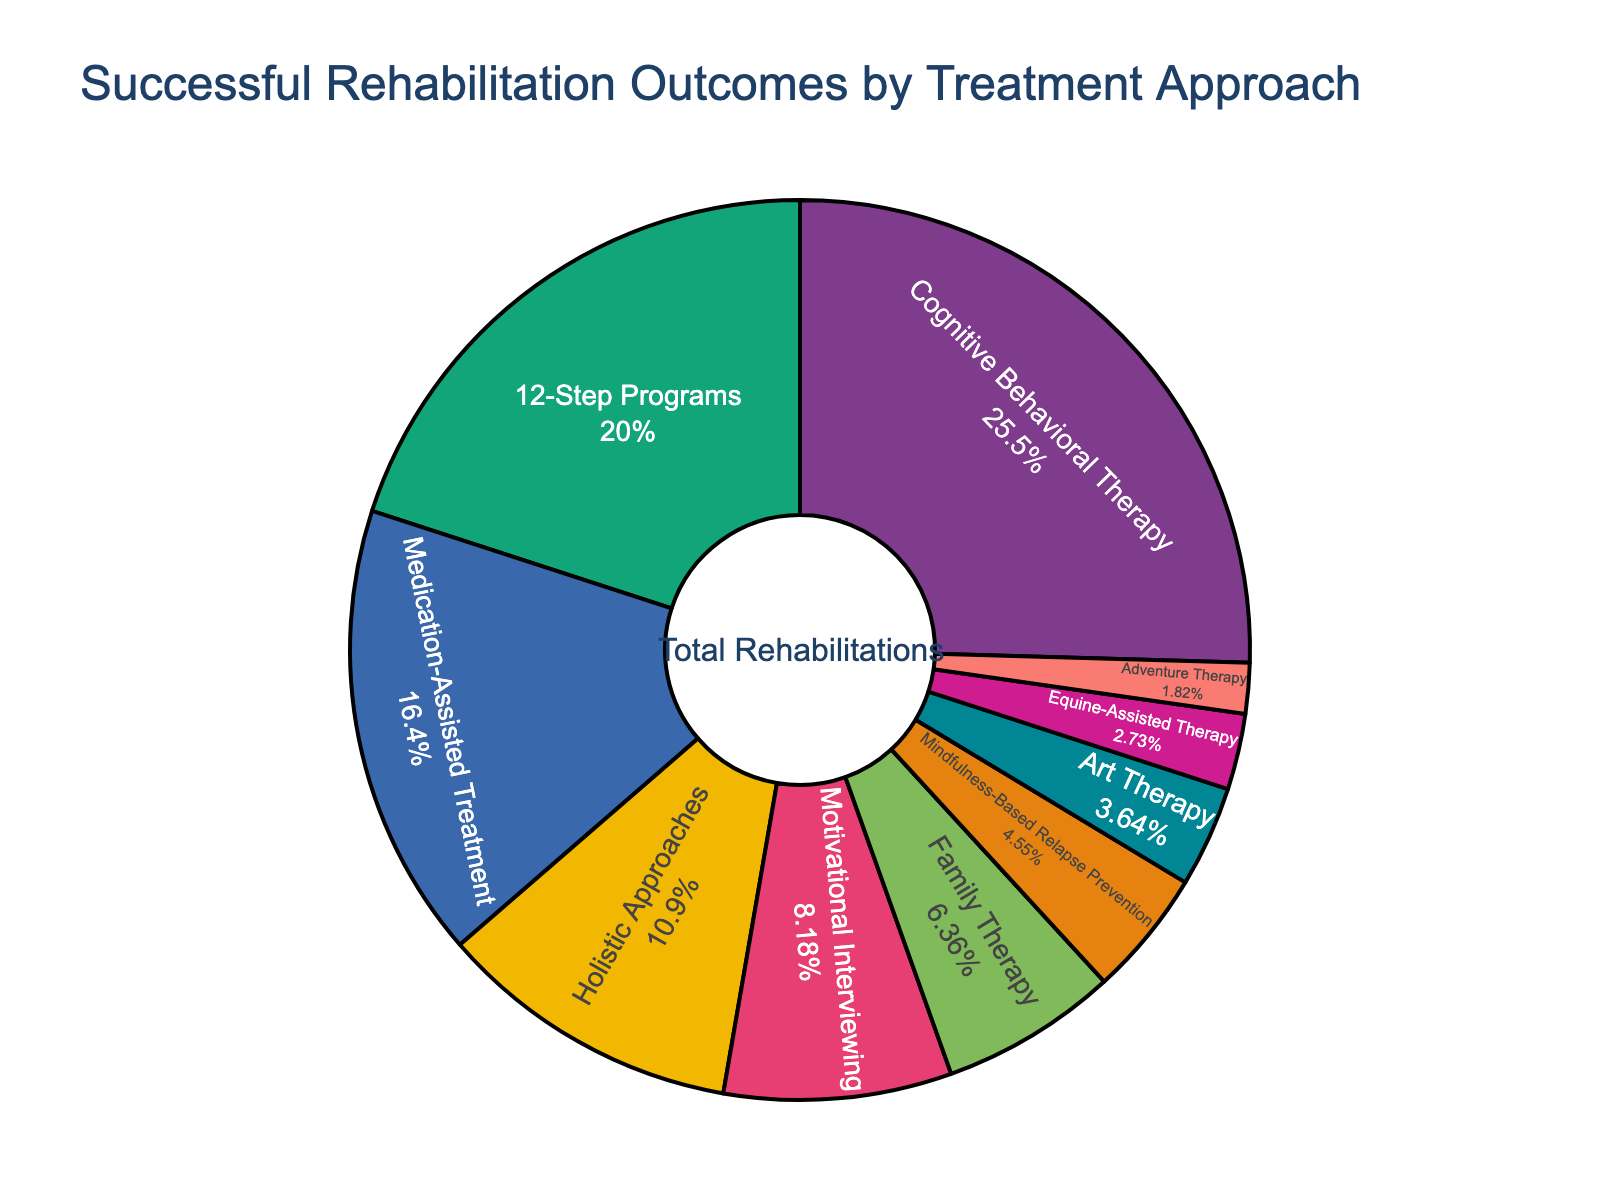What's the dominant treatment approach in terms of successful rehabilitation outcomes? To find the dominant treatment approach, look for the segment with the highest percentage on the pie chart. The "Cognitive Behavioral Therapy" segment is the largest, accounting for 28%.
Answer: Cognitive Behavioral Therapy Which treatment approach is the least effective based on the percentage of successful rehabilitation outcomes? To determine the least effective approach, identify the segment with the smallest percentage in the pie chart. "Adventure Therapy" has the smallest segment at 2%.
Answer: Adventure Therapy What is the combined percentage of successful outcomes for "12-Step Programs" and "Medication-Assisted Treatment"? Sum the percentages for "12-Step Programs" (22%) and "Medication-Assisted Treatment" (18%). The total is 22% + 18% = 40%.
Answer: 40% How does "Family Therapy" compare to "Holistic Approaches" in terms of successful rehabilitation outcomes? Compare the percentages of "Family Therapy" (7%) and "Holistic Approaches" (12%). "Holistic Approaches" has a higher percentage than "Family Therapy".
Answer: Holistic Approaches has a higher percentage Which treatment approaches together make up more than 50% of the successful outcomes? Calculate the cumulative percentages in descending order until exceeding 50%. "Cognitive Behavioral Therapy" (28%) + "12-Step Programs" (22%) sum to 50%, which is exactly 50%. Include the next one: "Medication-Assisted Treatment" (18%) to exceed 50%.
Answer: Cognitive Behavioral Therapy, 12-Step Programs, Medication-Assisted Treatment What percentage do "Mindfulness-Based Relapse Prevention" and "Art Therapy" contribute to successful rehabilitation outcomes? Add the percentages of "Mindfulness-Based Relapse Prevention" (5%) and "Art Therapy" (4%). The total is 5% + 4% = 9%.
Answer: 9% Compare the visual size of the sections for "Motivational Interviewing" and "Family Therapy". Which one is larger? Visually inspect the pie chart and compare the sizes of the "Motivational Interviewing" and "Family Therapy" segments. The "Motivational Interviewing" segment is slightly larger.
Answer: Motivational Interviewing What is the difference in the percentage of successful outcomes between "Cognitive Behavioral Therapy" and "Holistic Approaches"? Subtract the percentage of "Holistic Approaches" (12%) from "Cognitive Behavioral Therapy" (28%). The difference is 28% - 12% = 16%.
Answer: 16% Calculate the average percentage of successful rehabilitation outcomes for "Family Therapy", "Mindfulness-Based Relapse Prevention", and "Art Therapy". Sum the percentages of the three approaches: "Family Therapy" (7%), "Mindfulness-Based Relapse Prevention" (5%), and "Art Therapy" (4%). The total is 7% + 5% + 4% = 16%. Divide by 3 to find the average: 16% / 3 ≈ 5.33%.
Answer: 5.33% Which treatment approaches have a combined successful outcome percentage that is equal to "Cognitive Behavioral Therapy"? Identify approaches whose combined percentages equal "Cognitive Behavioral Therapy" (28%). The combined percentage of "12-Step Programs" (22%) and "Motivational Interviewing" (9%) equals 28%.
Answer: 12-Step Programs, Motivational Interviewing 